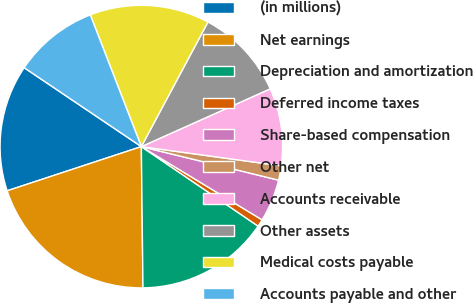<chart> <loc_0><loc_0><loc_500><loc_500><pie_chart><fcel>(in millions)<fcel>Net earnings<fcel>Depreciation and amortization<fcel>Deferred income taxes<fcel>Share-based compensation<fcel>Other net<fcel>Accounts receivable<fcel>Other assets<fcel>Medical costs payable<fcel>Accounts payable and other<nl><fcel>14.5%<fcel>20.12%<fcel>15.3%<fcel>0.84%<fcel>4.86%<fcel>1.64%<fcel>8.88%<fcel>10.48%<fcel>13.7%<fcel>9.68%<nl></chart> 